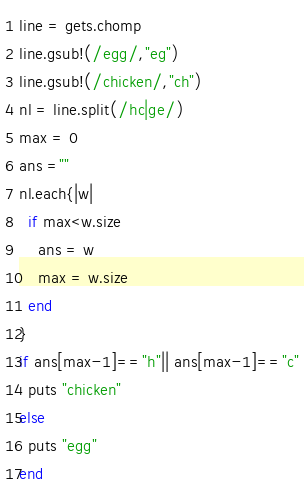Convert code to text. <code><loc_0><loc_0><loc_500><loc_500><_Ruby_>line = gets.chomp
line.gsub!(/egg/,"eg")
line.gsub!(/chicken/,"ch")
nl = line.split(/hc|ge/)
max = 0
ans =""
nl.each{|w|
  if max<w.size
    ans = w
    max = w.size
  end
}
if ans[max-1]=="h"|| ans[max-1]=="c"
  puts "chicken"
else
  puts "egg"
end</code> 